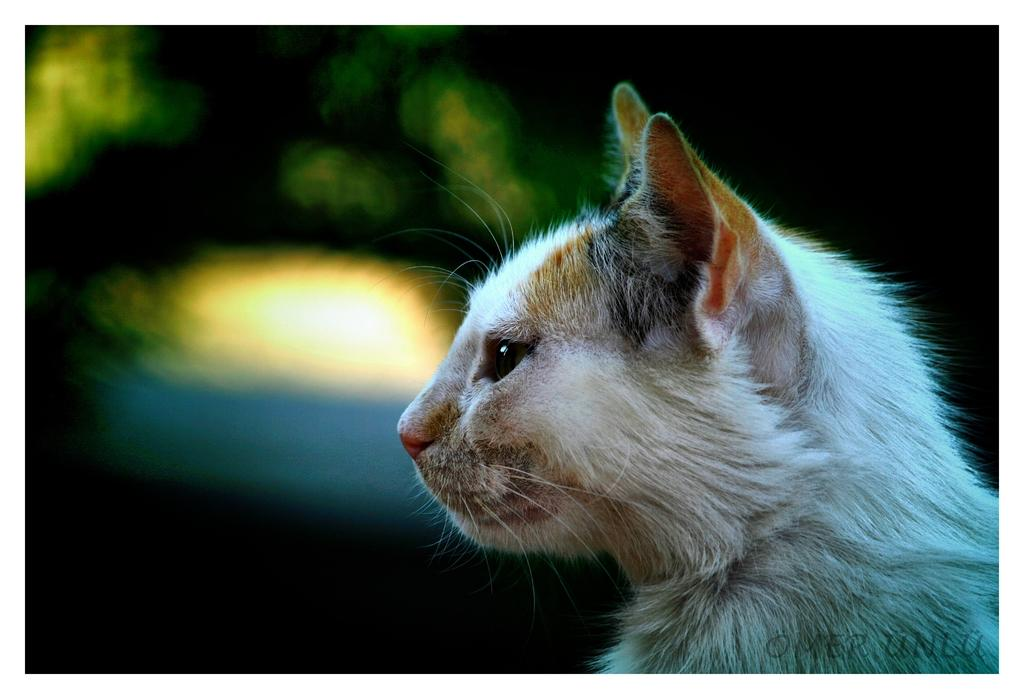What type of animal is in the image? There is a cat in the image. Can you describe the background of the image? The background of the image is blurred. How many passengers are visible in the image? There are no passengers present in the image, as it features a cat and a blurred background. What type of stick can be seen being used by the cat in the image? There is no stick present in the image, and the cat is not using any object. 